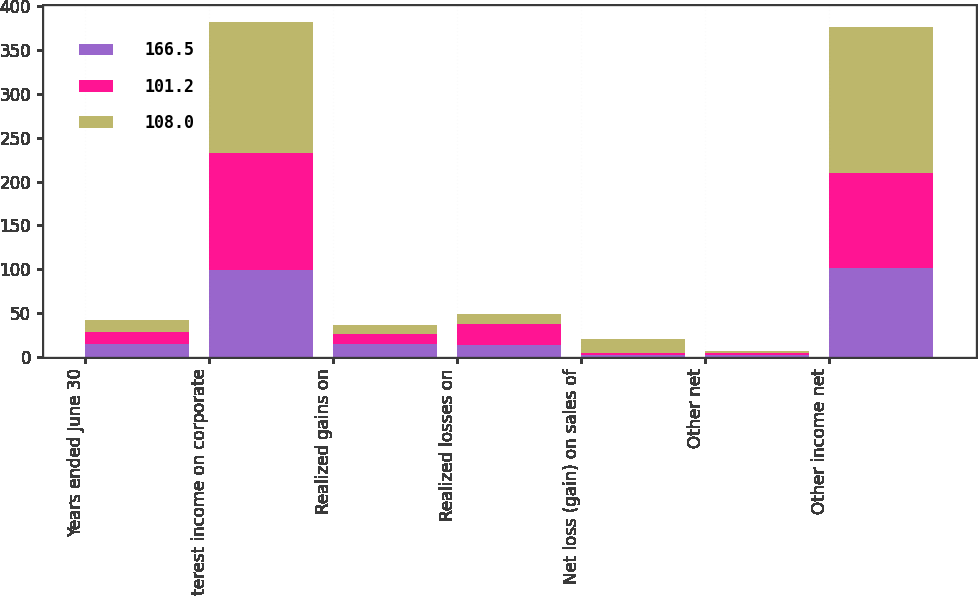<chart> <loc_0><loc_0><loc_500><loc_500><stacked_bar_chart><ecel><fcel>Years ended June 30<fcel>Interest income on corporate<fcel>Realized gains on<fcel>Realized losses on<fcel>Net loss (gain) on sales of<fcel>Other net<fcel>Other income net<nl><fcel>166.5<fcel>14.2<fcel>98.8<fcel>15<fcel>13.4<fcel>2.3<fcel>2.3<fcel>101.2<nl><fcel>101.2<fcel>14.2<fcel>134.2<fcel>11.4<fcel>23.8<fcel>2.2<fcel>2.3<fcel>108<nl><fcel>108<fcel>14.2<fcel>149.5<fcel>10.1<fcel>11.4<fcel>16<fcel>2.3<fcel>166.5<nl></chart> 